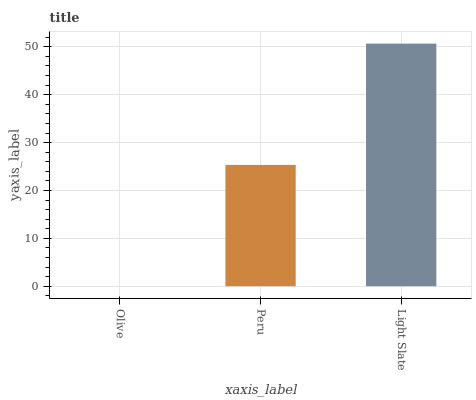Is Olive the minimum?
Answer yes or no. Yes. Is Light Slate the maximum?
Answer yes or no. Yes. Is Peru the minimum?
Answer yes or no. No. Is Peru the maximum?
Answer yes or no. No. Is Peru greater than Olive?
Answer yes or no. Yes. Is Olive less than Peru?
Answer yes or no. Yes. Is Olive greater than Peru?
Answer yes or no. No. Is Peru less than Olive?
Answer yes or no. No. Is Peru the high median?
Answer yes or no. Yes. Is Peru the low median?
Answer yes or no. Yes. Is Olive the high median?
Answer yes or no. No. Is Light Slate the low median?
Answer yes or no. No. 